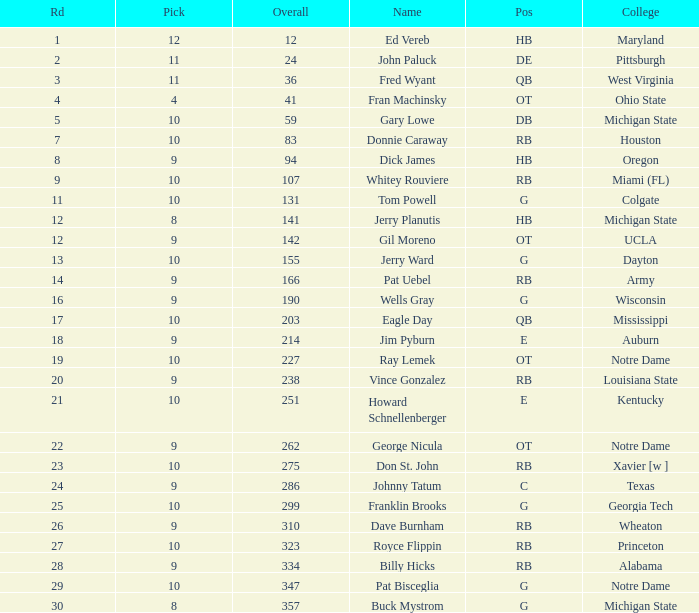What is the overall pick number for a draft pick smaller than 9, named buck mystrom from Michigan State college? 357.0. 